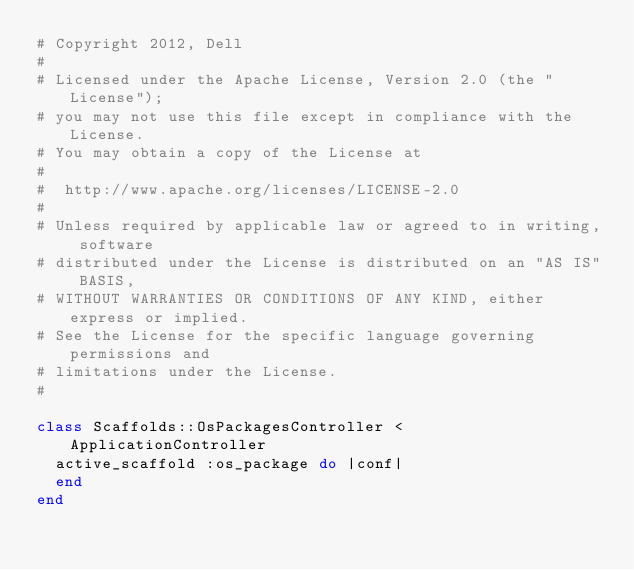<code> <loc_0><loc_0><loc_500><loc_500><_Ruby_># Copyright 2012, Dell
#
# Licensed under the Apache License, Version 2.0 (the "License");
# you may not use this file except in compliance with the License.
# You may obtain a copy of the License at
#
#  http://www.apache.org/licenses/LICENSE-2.0
#
# Unless required by applicable law or agreed to in writing, software
# distributed under the License is distributed on an "AS IS" BASIS,
# WITHOUT WARRANTIES OR CONDITIONS OF ANY KIND, either express or implied.
# See the License for the specific language governing permissions and
# limitations under the License.
#

class Scaffolds::OsPackagesController < ApplicationController
  active_scaffold :os_package do |conf|
  end
end 
</code> 